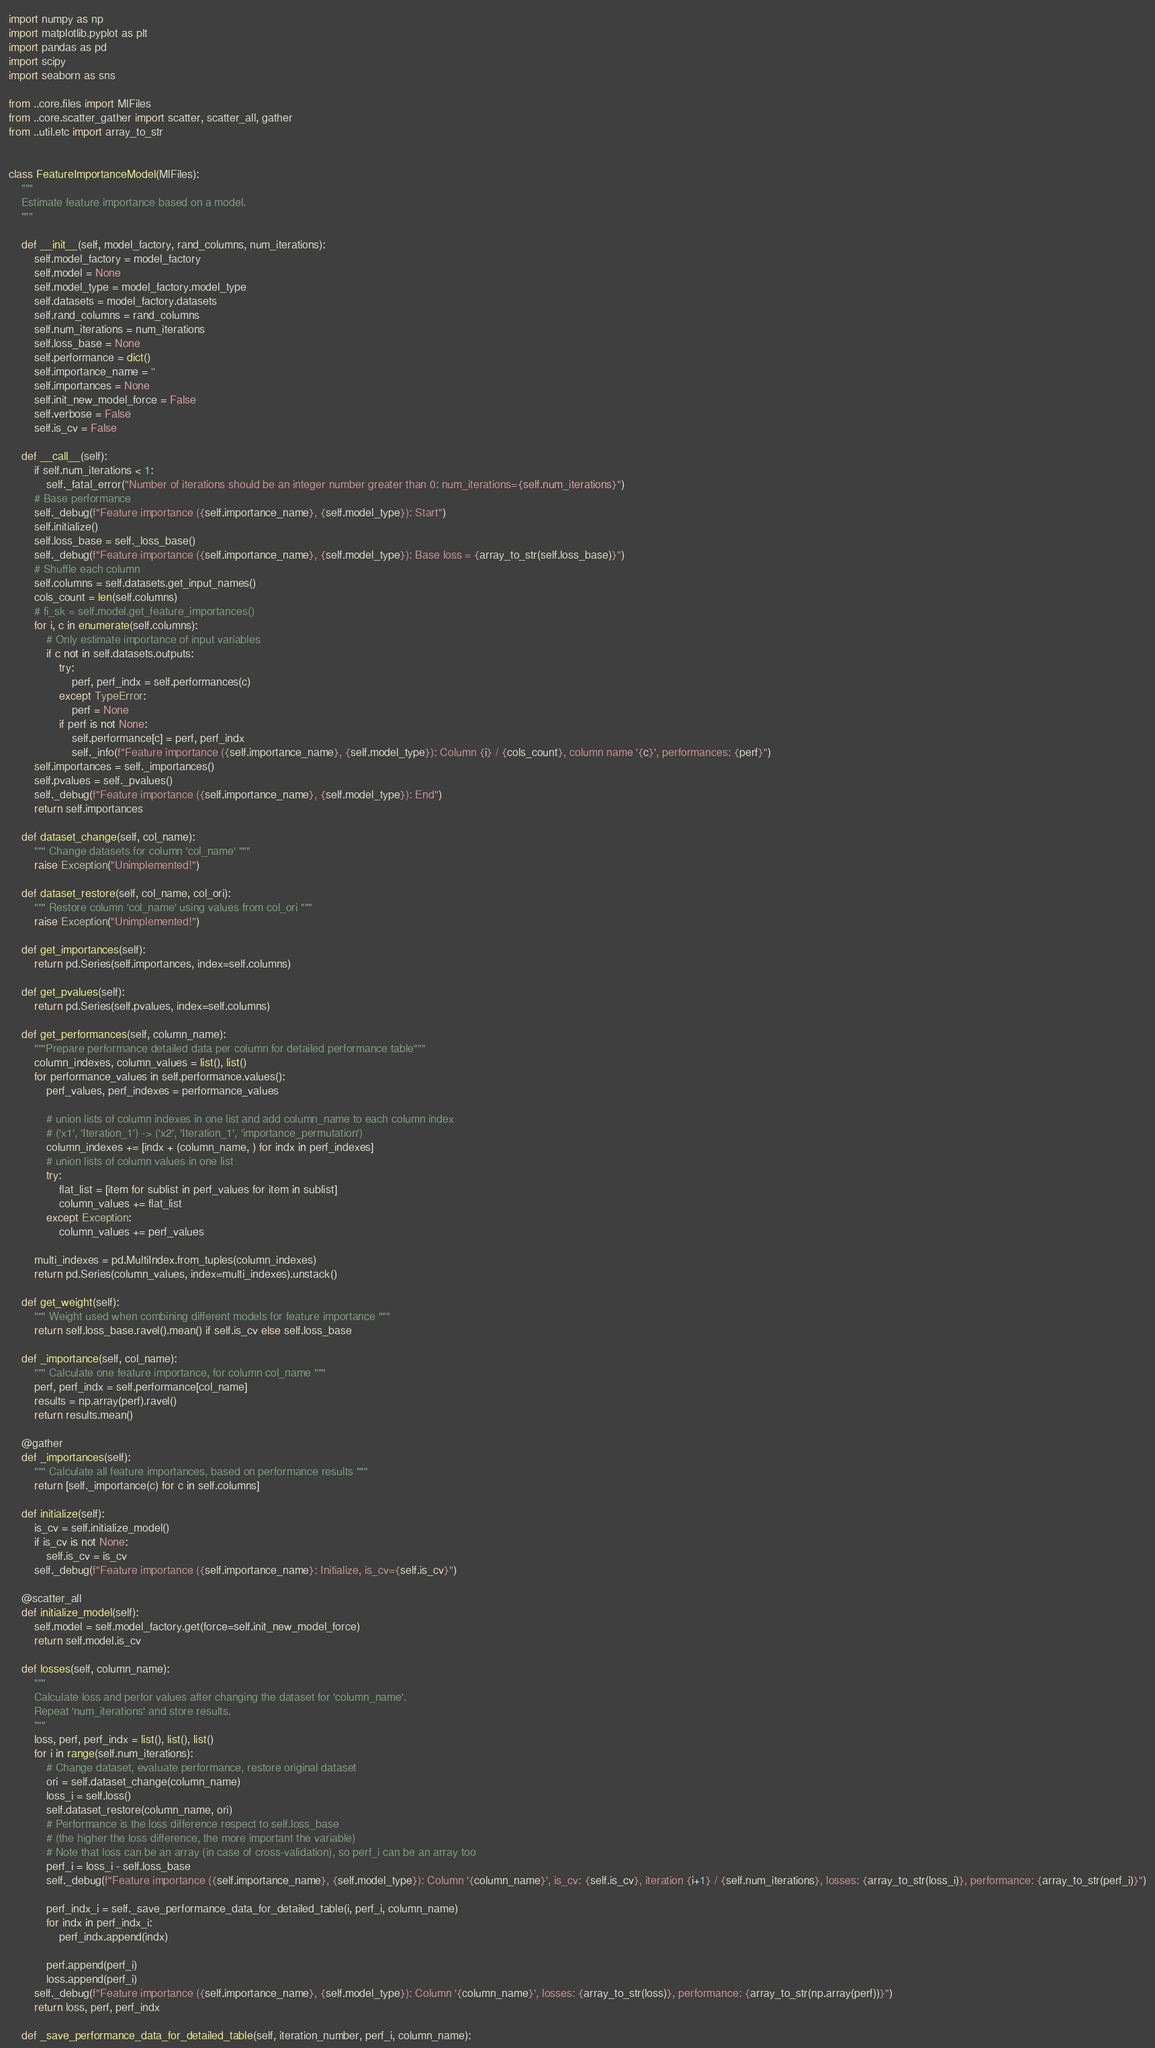<code> <loc_0><loc_0><loc_500><loc_500><_Python_>import numpy as np
import matplotlib.pyplot as plt
import pandas as pd
import scipy
import seaborn as sns

from ..core.files import MlFiles
from ..core.scatter_gather import scatter, scatter_all, gather
from ..util.etc import array_to_str


class FeatureImportanceModel(MlFiles):
    """
    Estimate feature importance based on a model.
    """

    def __init__(self, model_factory, rand_columns, num_iterations):
        self.model_factory = model_factory
        self.model = None
        self.model_type = model_factory.model_type
        self.datasets = model_factory.datasets
        self.rand_columns = rand_columns
        self.num_iterations = num_iterations
        self.loss_base = None
        self.performance = dict()
        self.importance_name = ''
        self.importances = None
        self.init_new_model_force = False
        self.verbose = False
        self.is_cv = False

    def __call__(self):
        if self.num_iterations < 1:
            self._fatal_error("Number of iterations should be an integer number greater than 0: num_iterations={self.num_iterations}")
        # Base performance
        self._debug(f"Feature importance ({self.importance_name}, {self.model_type}): Start")
        self.initialize()
        self.loss_base = self._loss_base()
        self._debug(f"Feature importance ({self.importance_name}, {self.model_type}): Base loss = {array_to_str(self.loss_base)}")
        # Shuffle each column
        self.columns = self.datasets.get_input_names()
        cols_count = len(self.columns)
        # fi_sk = self.model.get_feature_importances()
        for i, c in enumerate(self.columns):
            # Only estimate importance of input variables
            if c not in self.datasets.outputs:
                try:
                    perf, perf_indx = self.performances(c)
                except TypeError:
                    perf = None
                if perf is not None:
                    self.performance[c] = perf, perf_indx
                    self._info(f"Feature importance ({self.importance_name}, {self.model_type}): Column {i} / {cols_count}, column name '{c}', performances: {perf}")
        self.importances = self._importances()
        self.pvalues = self._pvalues()
        self._debug(f"Feature importance ({self.importance_name}, {self.model_type}): End")
        return self.importances

    def dataset_change(self, col_name):
        """ Change datasets for column 'col_name' """
        raise Exception("Unimplemented!")

    def dataset_restore(self, col_name, col_ori):
        """ Restore column 'col_name' using values from col_ori """
        raise Exception("Unimplemented!")

    def get_importances(self):
        return pd.Series(self.importances, index=self.columns)

    def get_pvalues(self):
        return pd.Series(self.pvalues, index=self.columns)

    def get_performances(self, column_name):
        """Prepare performance detailed data per column for detailed performance table"""
        column_indexes, column_values = list(), list()
        for performance_values in self.performance.values():
            perf_values, perf_indexes = performance_values

            # union lists of column indexes in one list and add column_name to each column index
            # ('x1', 'Iteration_1') -> ('x2', 'Iteration_1', 'importance_permutation')
            column_indexes += [indx + (column_name, ) for indx in perf_indexes]
            # union lists of column values in one list
            try:
                flat_list = [item for sublist in perf_values for item in sublist]
                column_values += flat_list
            except Exception:
                column_values += perf_values

        multi_indexes = pd.MultiIndex.from_tuples(column_indexes)
        return pd.Series(column_values, index=multi_indexes).unstack()

    def get_weight(self):
        """ Weight used when combining different models for feature importance """
        return self.loss_base.ravel().mean() if self.is_cv else self.loss_base

    def _importance(self, col_name):
        """ Calculate one feature importance, for column col_name """
        perf, perf_indx = self.performance[col_name]
        results = np.array(perf).ravel()
        return results.mean()

    @gather
    def _importances(self):
        """ Calculate all feature importances, based on performance results """
        return [self._importance(c) for c in self.columns]

    def initialize(self):
        is_cv = self.initialize_model()
        if is_cv is not None:
            self.is_cv = is_cv
        self._debug(f"Feature importance ({self.importance_name}: Initialize, is_cv={self.is_cv}")

    @scatter_all
    def initialize_model(self):
        self.model = self.model_factory.get(force=self.init_new_model_force)
        return self.model.is_cv

    def losses(self, column_name):
        """
        Calculate loss and perfor values after changing the dataset for 'column_name'.
        Repeat 'num_iterations' and store results.
        """
        loss, perf, perf_indx = list(), list(), list()
        for i in range(self.num_iterations):
            # Change dataset, evaluate performance, restore original dataset
            ori = self.dataset_change(column_name)
            loss_i = self.loss()
            self.dataset_restore(column_name, ori)
            # Performance is the loss difference respect to self.loss_base
            # (the higher the loss difference, the more important the variable)
            # Note that loss can be an array (in case of cross-validation), so perf_i can be an array too
            perf_i = loss_i - self.loss_base
            self._debug(f"Feature importance ({self.importance_name}, {self.model_type}): Column '{column_name}', is_cv: {self.is_cv}, iteration {i+1} / {self.num_iterations}, losses: {array_to_str(loss_i)}, performance: {array_to_str(perf_i)}")

            perf_indx_i = self._save_performance_data_for_detailed_table(i, perf_i, column_name)
            for indx in perf_indx_i:
                perf_indx.append(indx)

            perf.append(perf_i)
            loss.append(perf_i)
        self._debug(f"Feature importance ({self.importance_name}, {self.model_type}): Column '{column_name}', losses: {array_to_str(loss)}, performance: {array_to_str(np.array(perf))}")
        return loss, perf, perf_indx

    def _save_performance_data_for_detailed_table(self, iteration_number, perf_i, column_name):</code> 